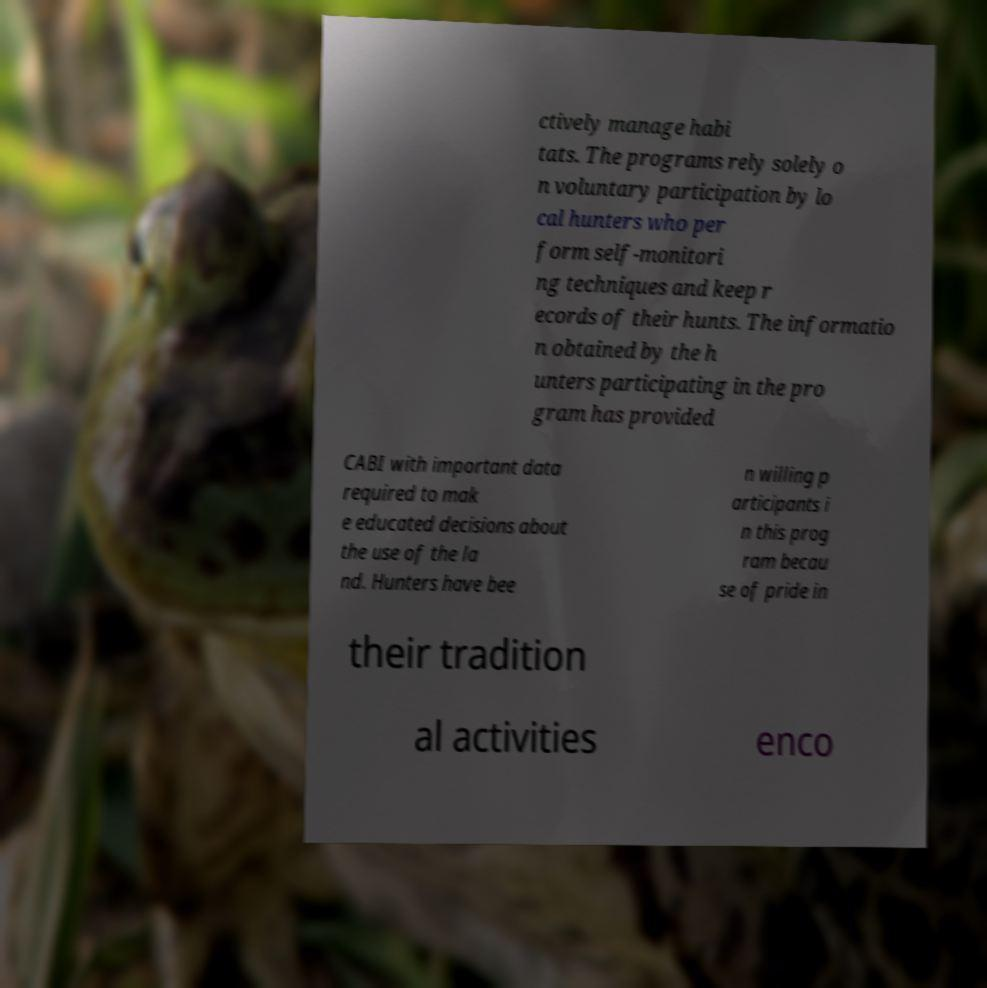Could you assist in decoding the text presented in this image and type it out clearly? ctively manage habi tats. The programs rely solely o n voluntary participation by lo cal hunters who per form self-monitori ng techniques and keep r ecords of their hunts. The informatio n obtained by the h unters participating in the pro gram has provided CABI with important data required to mak e educated decisions about the use of the la nd. Hunters have bee n willing p articipants i n this prog ram becau se of pride in their tradition al activities enco 